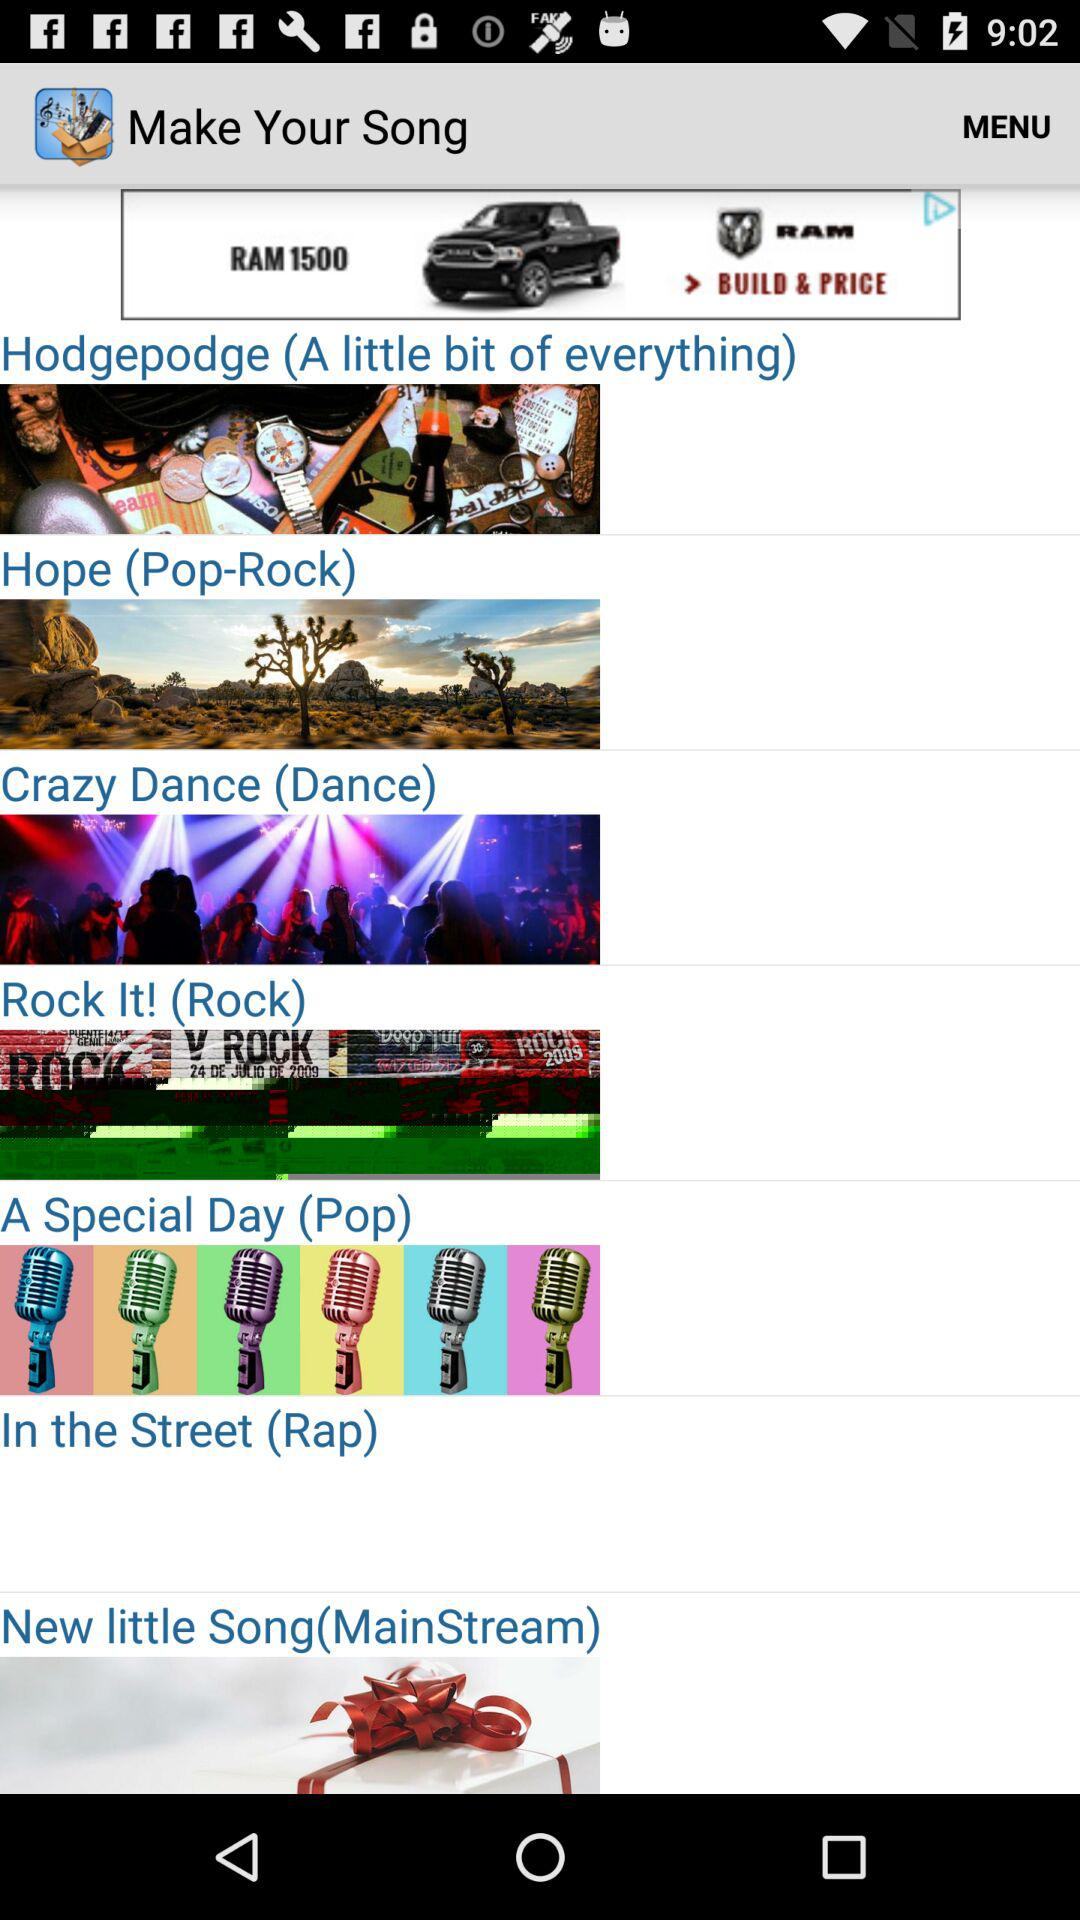What is the name of the application? The name of the application is "Make Your Song". 